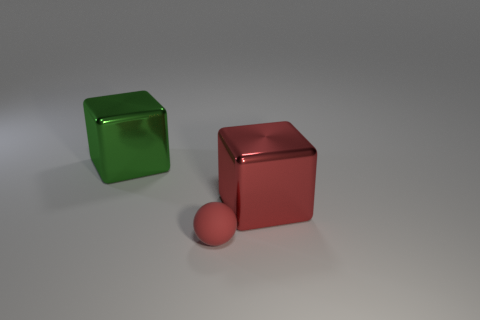There is a thing that is the same color as the tiny ball; what shape is it?
Ensure brevity in your answer.  Cube. The metal thing that is the same color as the matte thing is what size?
Provide a short and direct response. Large. What number of purple things are either small objects or large metal cubes?
Your answer should be compact. 0. How many other things are the same shape as the big green shiny object?
Make the answer very short. 1. There is a thing that is behind the small matte object and left of the red metal object; what is its shape?
Ensure brevity in your answer.  Cube. There is a red rubber thing; are there any big green metallic cubes on the right side of it?
Give a very brief answer. No. There is a green metallic thing that is the same shape as the large red metallic thing; what is its size?
Give a very brief answer. Large. Is there any other thing that is the same size as the red shiny thing?
Your response must be concise. Yes. Is the shape of the big green shiny thing the same as the tiny red matte object?
Make the answer very short. No. There is a red object that is on the left side of the big red metal block behind the tiny red ball; what size is it?
Provide a succinct answer. Small. 